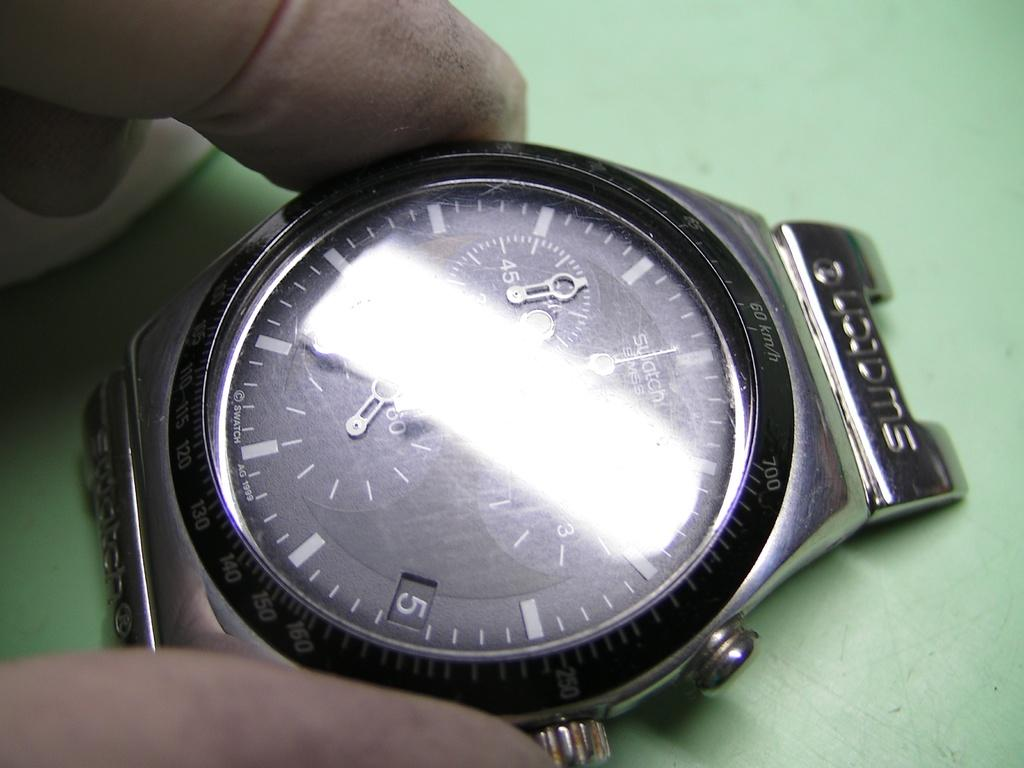<image>
Summarize the visual content of the image. A watch shows the words "swatch swiss" on the face. 